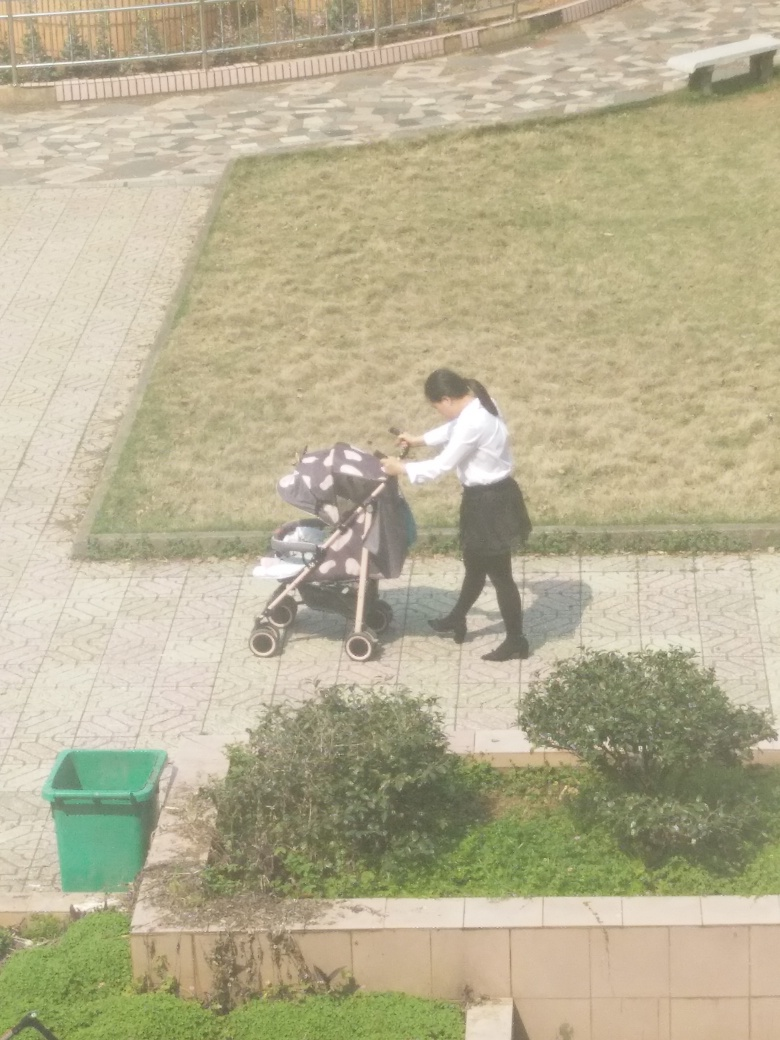What time of day does this scene look like it's taking place? The brightness and the shadows suggest it's likely midday or early afternoon. These are typically the times when the sun is high, resulting in shorter shadows and a well-lit environment. 